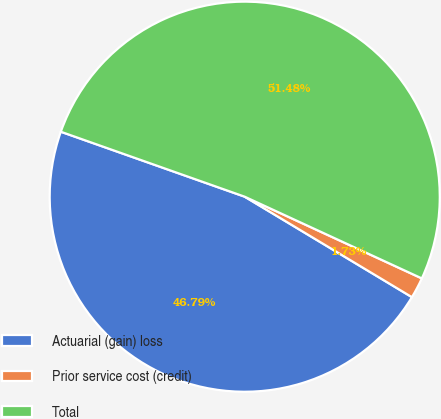Convert chart to OTSL. <chart><loc_0><loc_0><loc_500><loc_500><pie_chart><fcel>Actuarial (gain) loss<fcel>Prior service cost (credit)<fcel>Total<nl><fcel>46.79%<fcel>1.73%<fcel>51.47%<nl></chart> 